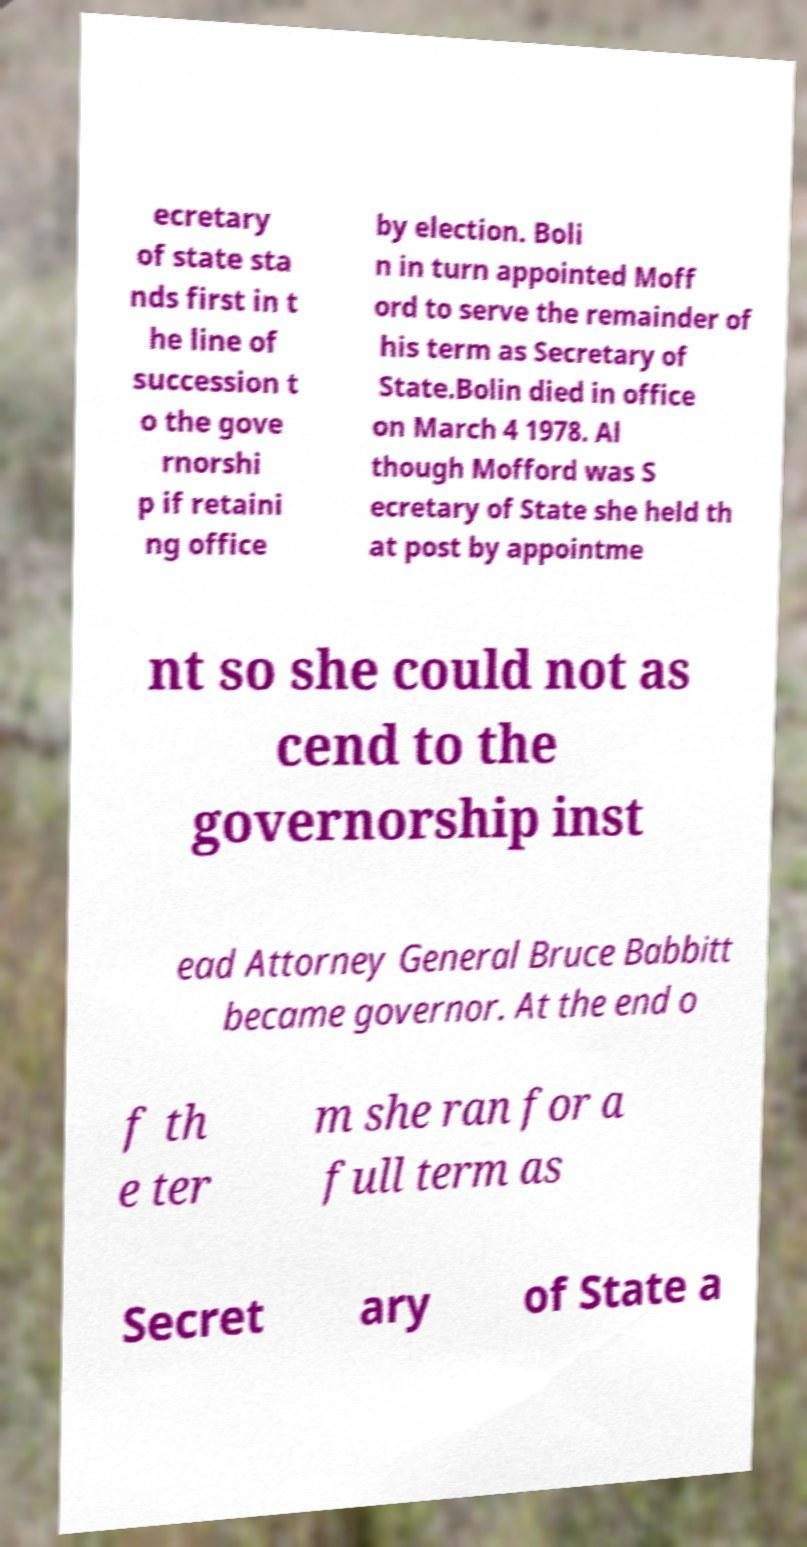Can you accurately transcribe the text from the provided image for me? ecretary of state sta nds first in t he line of succession t o the gove rnorshi p if retaini ng office by election. Boli n in turn appointed Moff ord to serve the remainder of his term as Secretary of State.Bolin died in office on March 4 1978. Al though Mofford was S ecretary of State she held th at post by appointme nt so she could not as cend to the governorship inst ead Attorney General Bruce Babbitt became governor. At the end o f th e ter m she ran for a full term as Secret ary of State a 